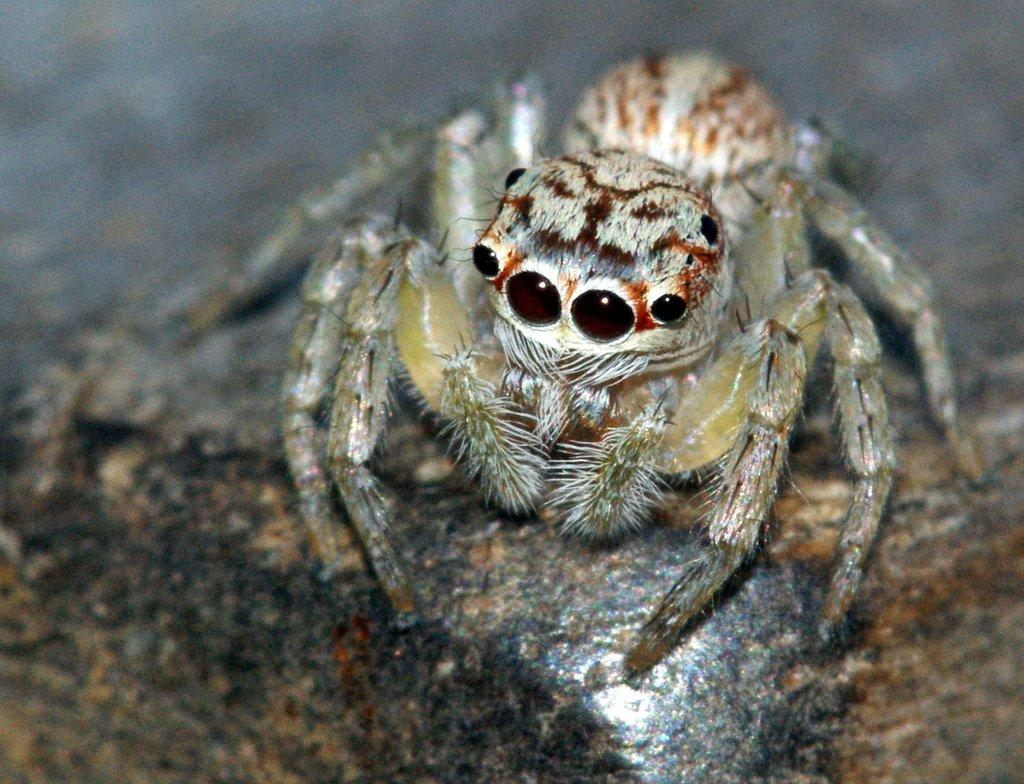What is the main subject of the image? There is a spider in the image. Can you describe the background of the image? The background of the image is blurry. Reasoning: Let' Let's think step by step in order to produce the conversation. We start by identifying the main subject of the image, which is the spider. Then, we describe the background of the image, noting that it is blurry. We avoid yes/no questions and ensure that the language is simple and clear. Absurd Question/Answer: What type of cap is the goose wearing in the image? There is no goose or cap present in the image. 